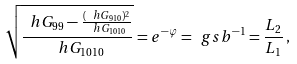Convert formula to latex. <formula><loc_0><loc_0><loc_500><loc_500>\sqrt { \frac { \ h G _ { 9 9 } - \frac { ( \ h G _ { 9 1 0 } ) ^ { 2 } } { \ h G _ { 1 0 1 0 } } } { \ h G _ { 1 0 1 0 } } } = e ^ { - \varphi } = \ g s b ^ { - 1 } = \frac { L _ { 2 } } { L _ { 1 } } \, ,</formula> 